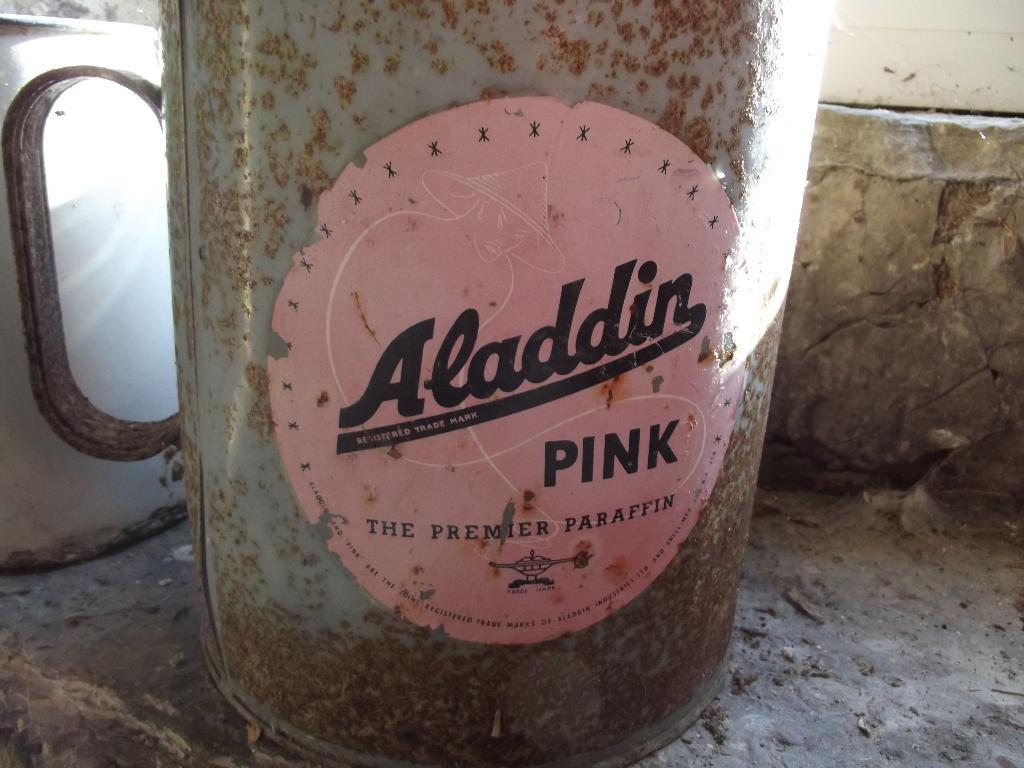What type of mug is in the image? There is a steel mug in the image. Where is the mug located? The mug is on a concrete surface. What can be seen on the left side of the image? There appears to be a mirror on the left side of the image. What advice is the mailbox giving to the mug in the image? There is no mailbox present in the image, so it cannot provide any advice to the mug. 